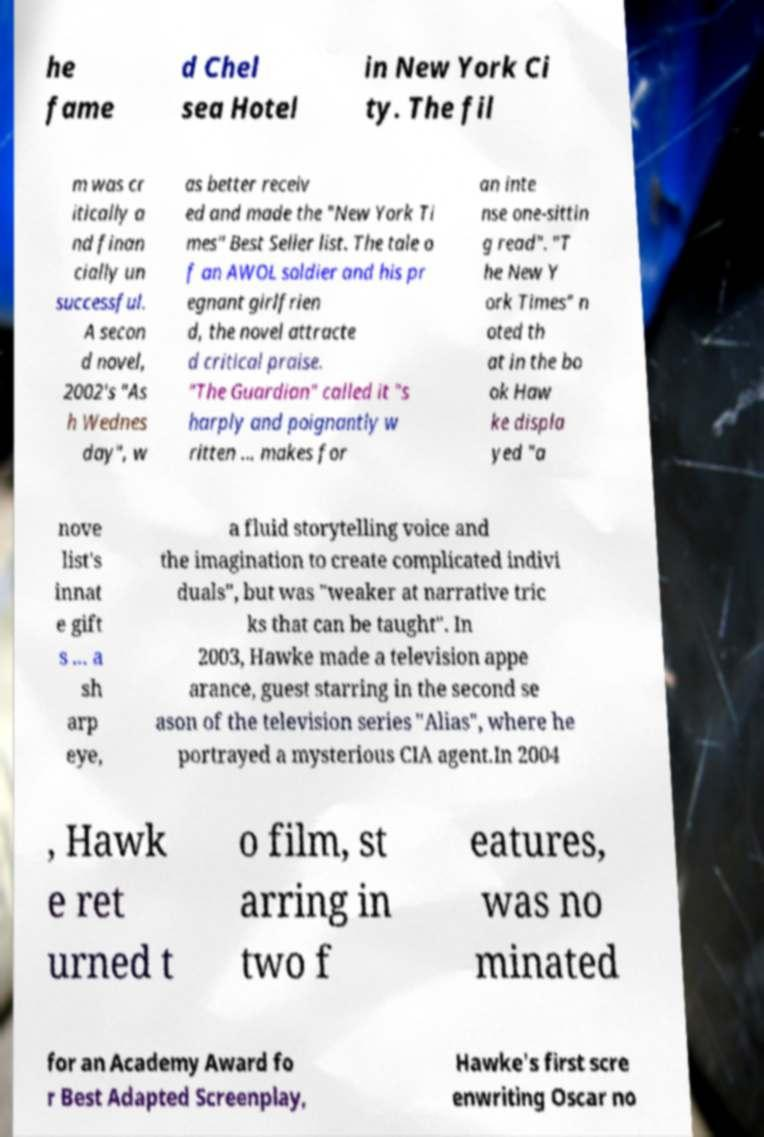There's text embedded in this image that I need extracted. Can you transcribe it verbatim? he fame d Chel sea Hotel in New York Ci ty. The fil m was cr itically a nd finan cially un successful. A secon d novel, 2002's "As h Wednes day", w as better receiv ed and made the "New York Ti mes" Best Seller list. The tale o f an AWOL soldier and his pr egnant girlfrien d, the novel attracte d critical praise. "The Guardian" called it "s harply and poignantly w ritten ... makes for an inte nse one-sittin g read". "T he New Y ork Times" n oted th at in the bo ok Haw ke displa yed "a nove list's innat e gift s ... a sh arp eye, a fluid storytelling voice and the imagination to create complicated indivi duals", but was "weaker at narrative tric ks that can be taught". In 2003, Hawke made a television appe arance, guest starring in the second se ason of the television series "Alias", where he portrayed a mysterious CIA agent.In 2004 , Hawk e ret urned t o film, st arring in two f eatures, was no minated for an Academy Award fo r Best Adapted Screenplay, Hawke's first scre enwriting Oscar no 